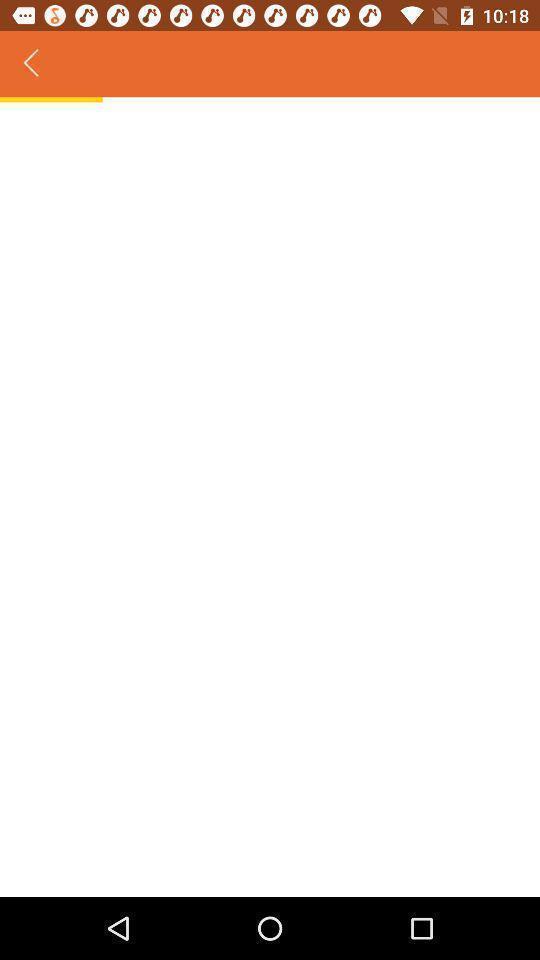What details can you identify in this image? Page that which is still loading. 